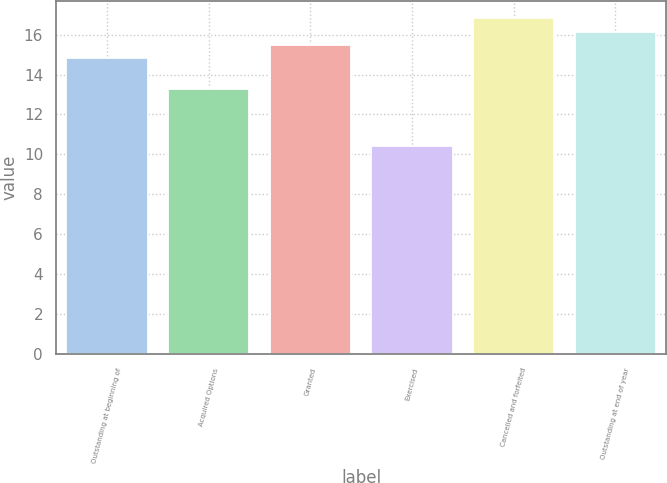Convert chart to OTSL. <chart><loc_0><loc_0><loc_500><loc_500><bar_chart><fcel>Outstanding at beginning of<fcel>Acquired Options<fcel>Granted<fcel>Exercised<fcel>Cancelled and forfeited<fcel>Outstanding at end of year<nl><fcel>14.84<fcel>13.26<fcel>15.48<fcel>10.43<fcel>16.84<fcel>16.12<nl></chart> 